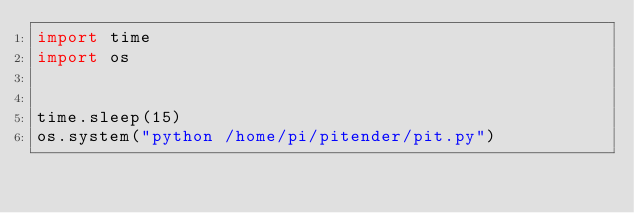<code> <loc_0><loc_0><loc_500><loc_500><_Python_>import time
import os


time.sleep(15)
os.system("python /home/pi/pitender/pit.py")


</code> 